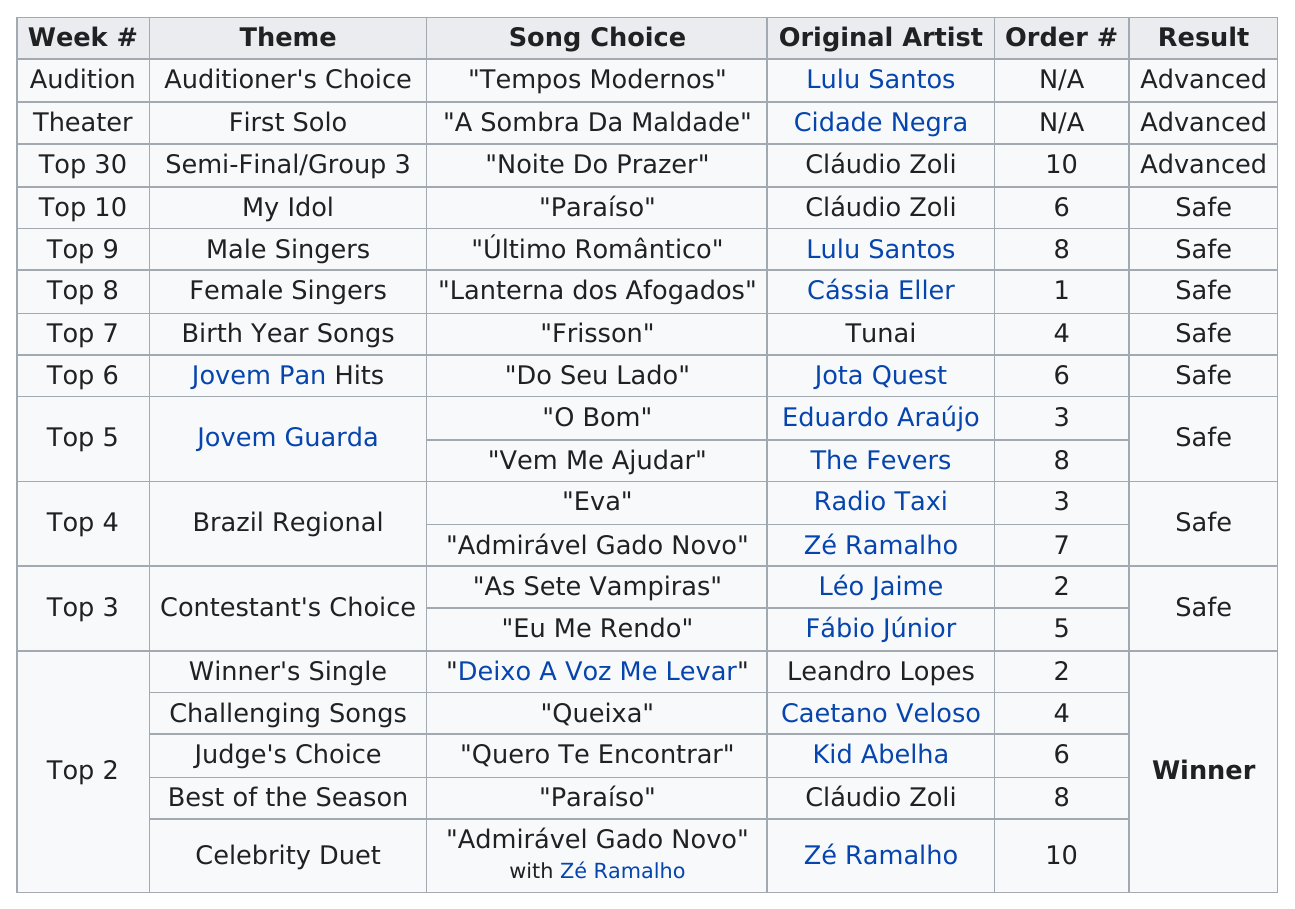Outline some significant characteristics in this image. Lopes sang "Lanterna dos Afogados" before singing "Frisson. The choice of the judge or the song from the year of birth, birth year songs are the preferred option. The order number of the top 30 is 10. The order of the top 6 is greater than that of the top 8. The number of songs sung by Cláudio Zoli is 3. 